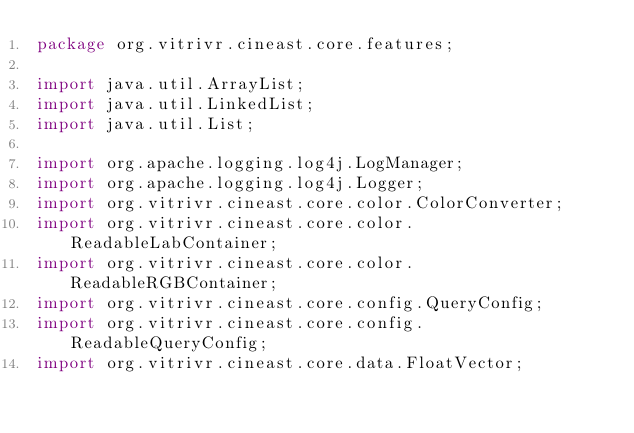<code> <loc_0><loc_0><loc_500><loc_500><_Java_>package org.vitrivr.cineast.core.features;

import java.util.ArrayList;
import java.util.LinkedList;
import java.util.List;

import org.apache.logging.log4j.LogManager;
import org.apache.logging.log4j.Logger;
import org.vitrivr.cineast.core.color.ColorConverter;
import org.vitrivr.cineast.core.color.ReadableLabContainer;
import org.vitrivr.cineast.core.color.ReadableRGBContainer;
import org.vitrivr.cineast.core.config.QueryConfig;
import org.vitrivr.cineast.core.config.ReadableQueryConfig;
import org.vitrivr.cineast.core.data.FloatVector;</code> 